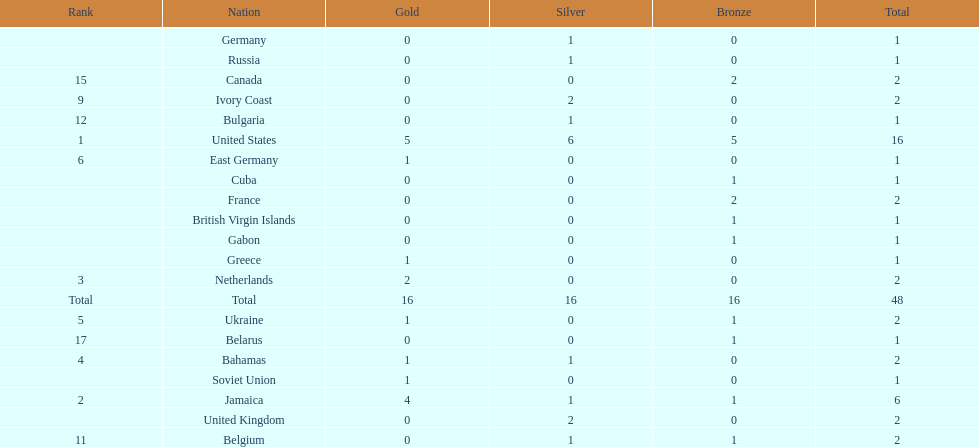How many nations received more medals than canada? 2. Parse the table in full. {'header': ['Rank', 'Nation', 'Gold', 'Silver', 'Bronze', 'Total'], 'rows': [['', 'Germany', '0', '1', '0', '1'], ['', 'Russia', '0', '1', '0', '1'], ['15', 'Canada', '0', '0', '2', '2'], ['9', 'Ivory Coast', '0', '2', '0', '2'], ['12', 'Bulgaria', '0', '1', '0', '1'], ['1', 'United States', '5', '6', '5', '16'], ['6', 'East Germany', '1', '0', '0', '1'], ['', 'Cuba', '0', '0', '1', '1'], ['', 'France', '0', '0', '2', '2'], ['', 'British Virgin Islands', '0', '0', '1', '1'], ['', 'Gabon', '0', '0', '1', '1'], ['', 'Greece', '1', '0', '0', '1'], ['3', 'Netherlands', '2', '0', '0', '2'], ['Total', 'Total', '16', '16', '16', '48'], ['5', 'Ukraine', '1', '0', '1', '2'], ['17', 'Belarus', '0', '0', '1', '1'], ['4', 'Bahamas', '1', '1', '0', '2'], ['', 'Soviet Union', '1', '0', '0', '1'], ['2', 'Jamaica', '4', '1', '1', '6'], ['', 'United Kingdom', '0', '2', '0', '2'], ['11', 'Belgium', '0', '1', '1', '2']]} 